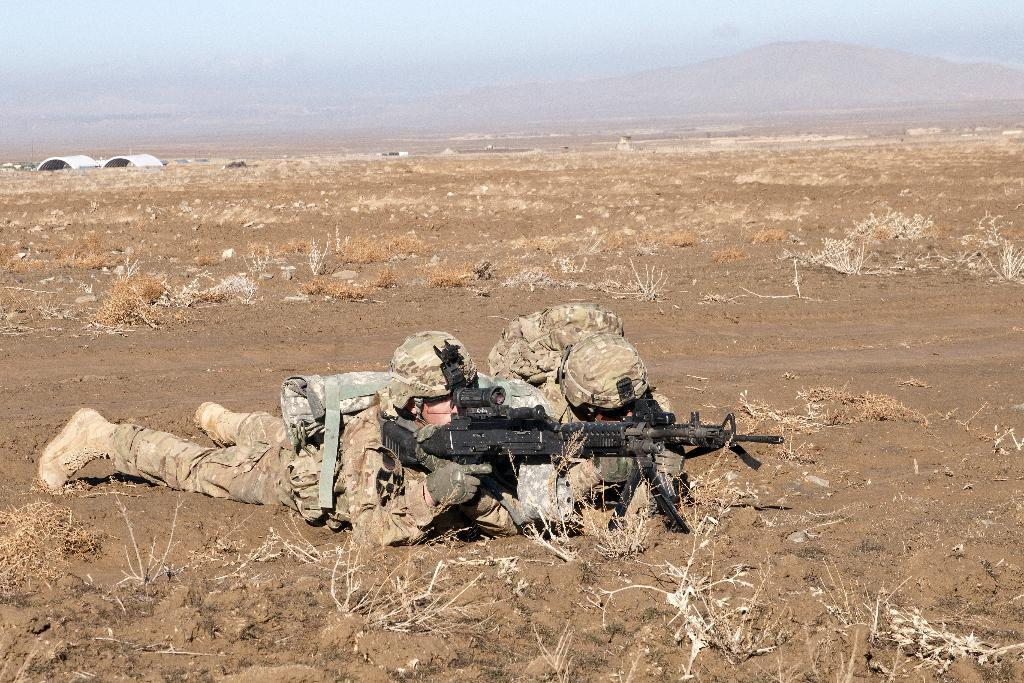How many people are in the image? There are two persons in the image. What are the persons wearing? The persons are wearing military dress. What action are the persons performing in the image? The persons are crawling on the ground. What objects are the persons holding in their hands? The persons are holding guns in their hands. What type of drum can be heard playing in the background of the image? There is no drum or sound present in the image; it is a still image of two persons in military dress crawling on the ground while holding guns. 